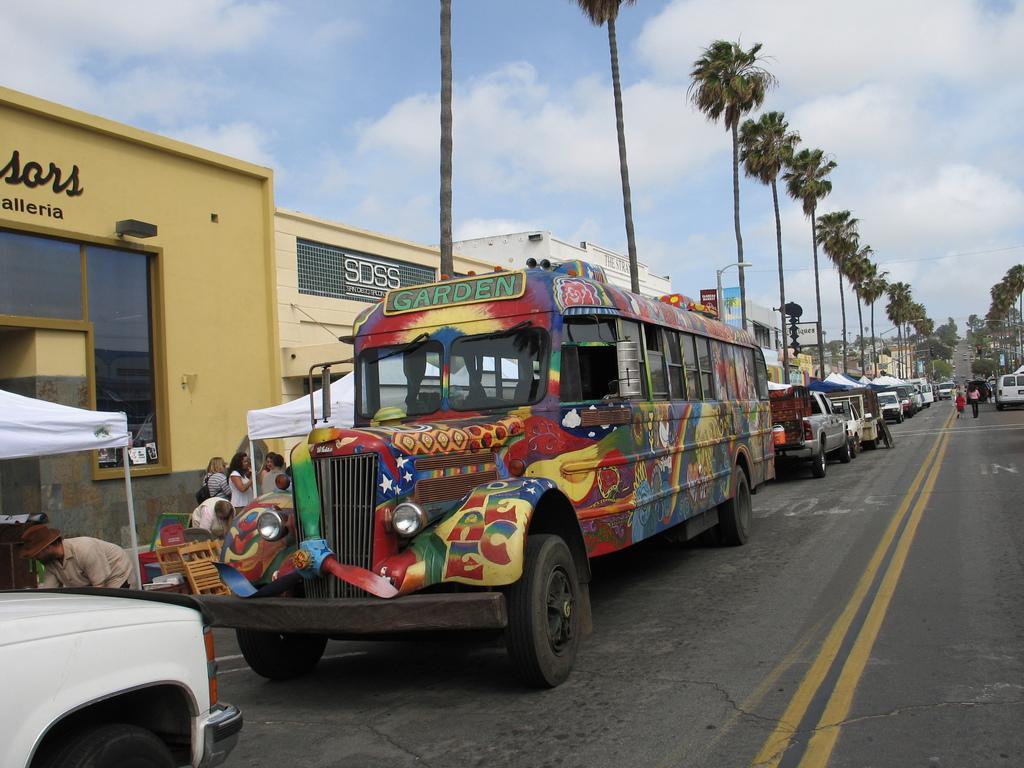What can be seen on the road in the image? There are vehicles on the road in the image. What is visible in the background of the image? The sky, clouds, buildings, trees, tents, and people are visible in the background of the image. Can you describe the sky in the image? The sky is visible in the background of the image. What other objects can be seen in the background of the image? There are other objects in the background of the image, but their specific details are not mentioned in the provided facts. What type of creature is performing a show in the image? There is no creature performing a show in the image. How many hands are visible in the image? The provided facts do not mention any hands visible in the image. 